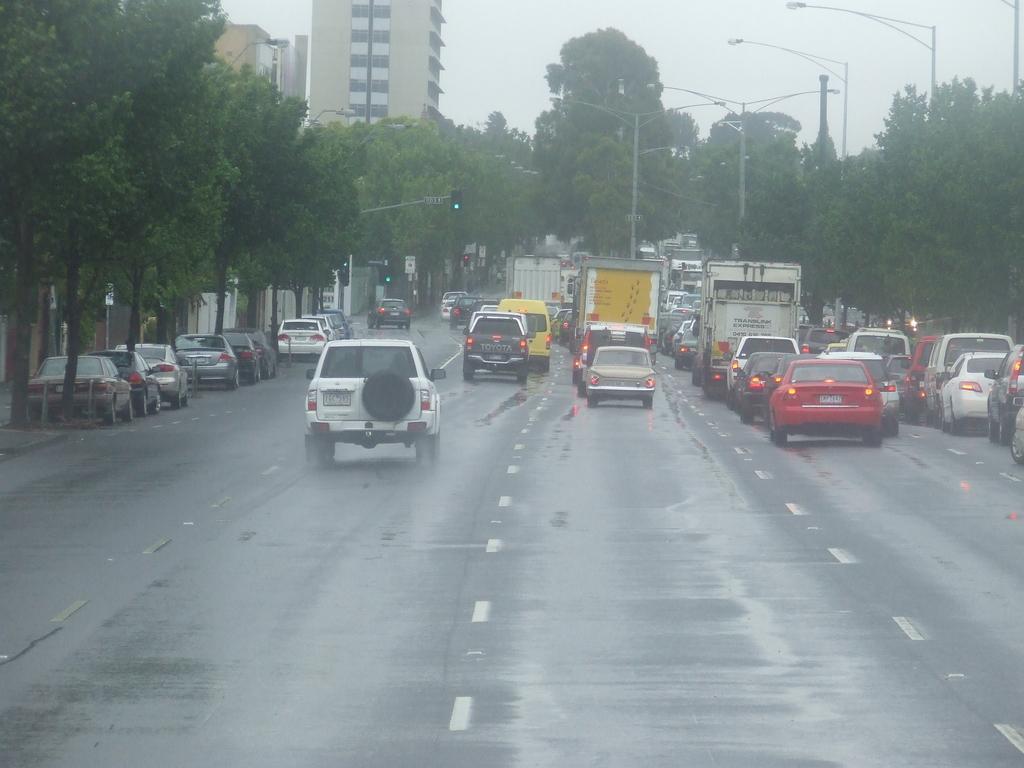Please provide a concise description of this image. In this picture we can see vehicles on the road, trees, traffic signals, buildings, poles with lights and some objects and in the background we can see the sky. 